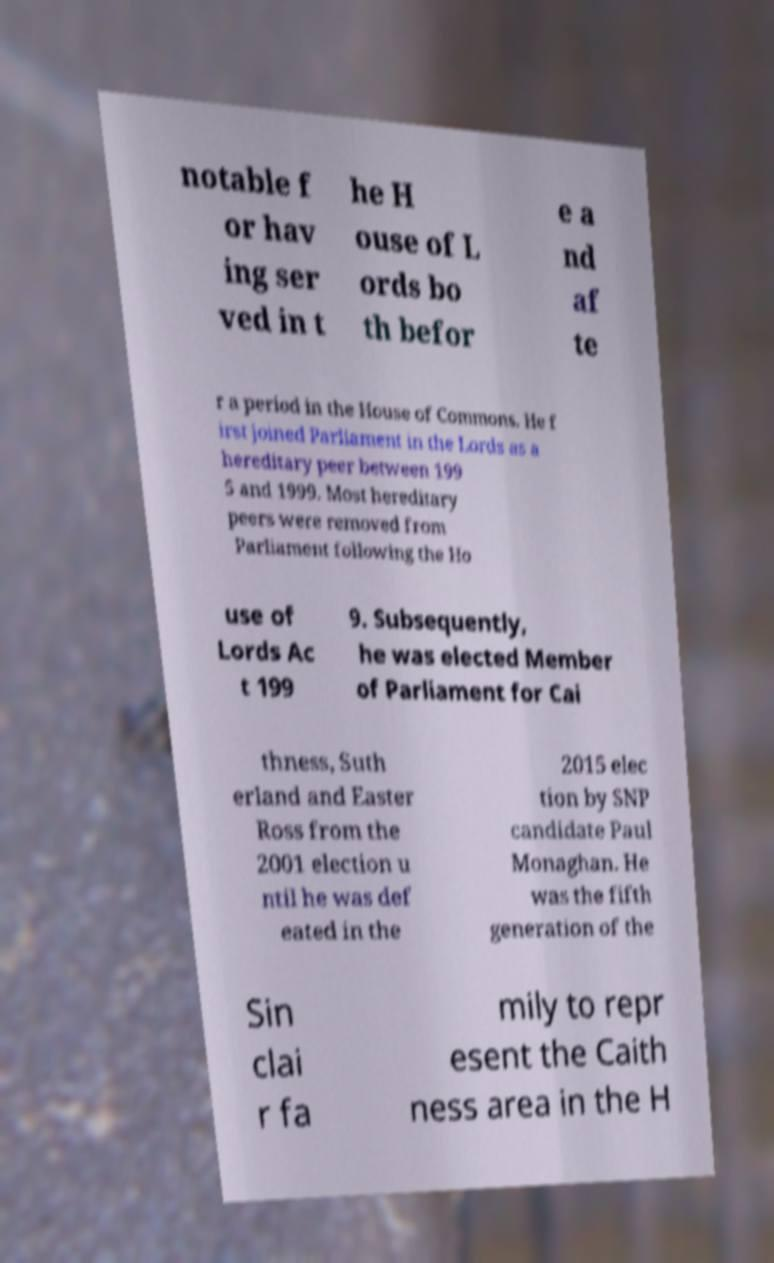Can you accurately transcribe the text from the provided image for me? notable f or hav ing ser ved in t he H ouse of L ords bo th befor e a nd af te r a period in the House of Commons. He f irst joined Parliament in the Lords as a hereditary peer between 199 5 and 1999. Most hereditary peers were removed from Parliament following the Ho use of Lords Ac t 199 9. Subsequently, he was elected Member of Parliament for Cai thness, Suth erland and Easter Ross from the 2001 election u ntil he was def eated in the 2015 elec tion by SNP candidate Paul Monaghan. He was the fifth generation of the Sin clai r fa mily to repr esent the Caith ness area in the H 